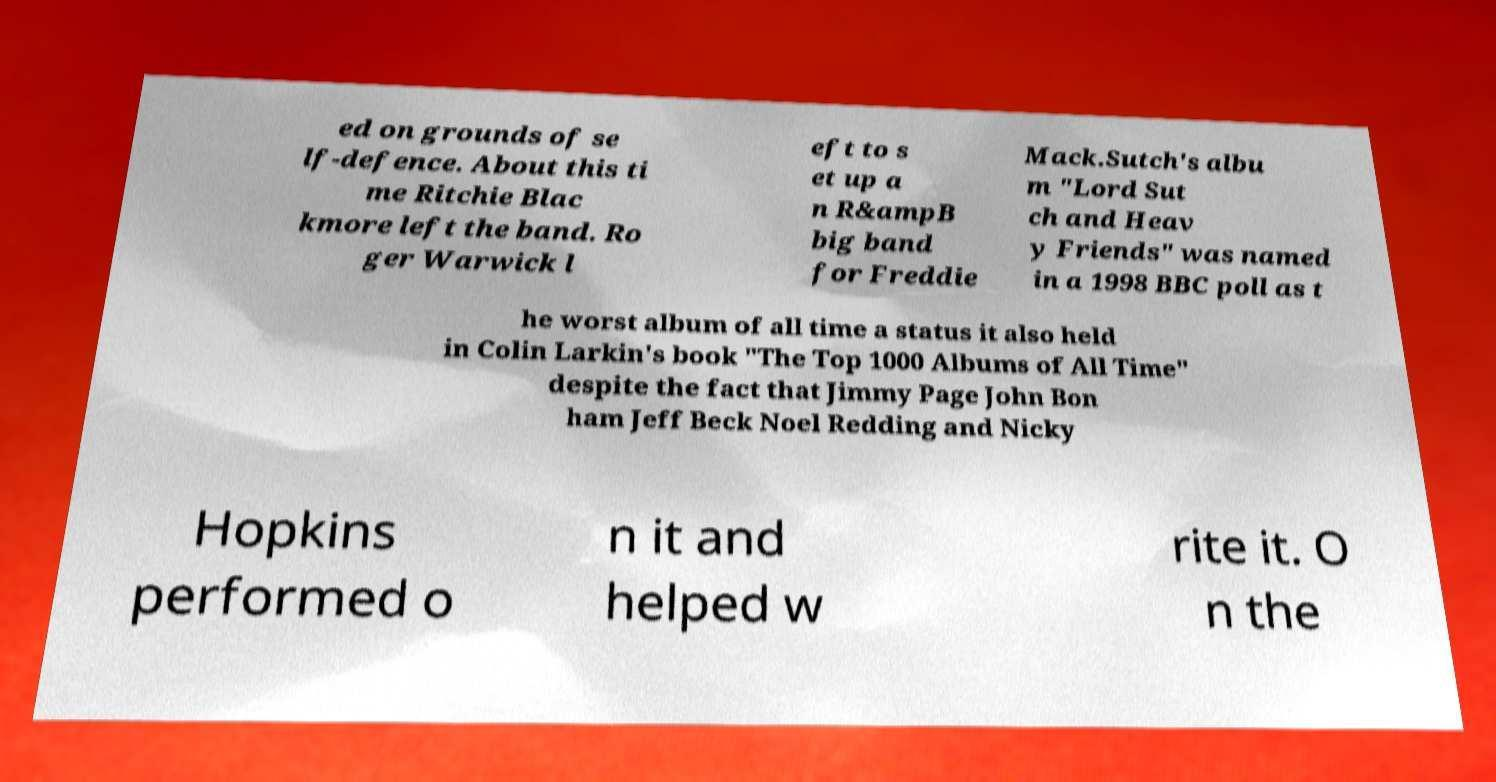What messages or text are displayed in this image? I need them in a readable, typed format. ed on grounds of se lf-defence. About this ti me Ritchie Blac kmore left the band. Ro ger Warwick l eft to s et up a n R&ampB big band for Freddie Mack.Sutch's albu m "Lord Sut ch and Heav y Friends" was named in a 1998 BBC poll as t he worst album of all time a status it also held in Colin Larkin's book "The Top 1000 Albums of All Time" despite the fact that Jimmy Page John Bon ham Jeff Beck Noel Redding and Nicky Hopkins performed o n it and helped w rite it. O n the 